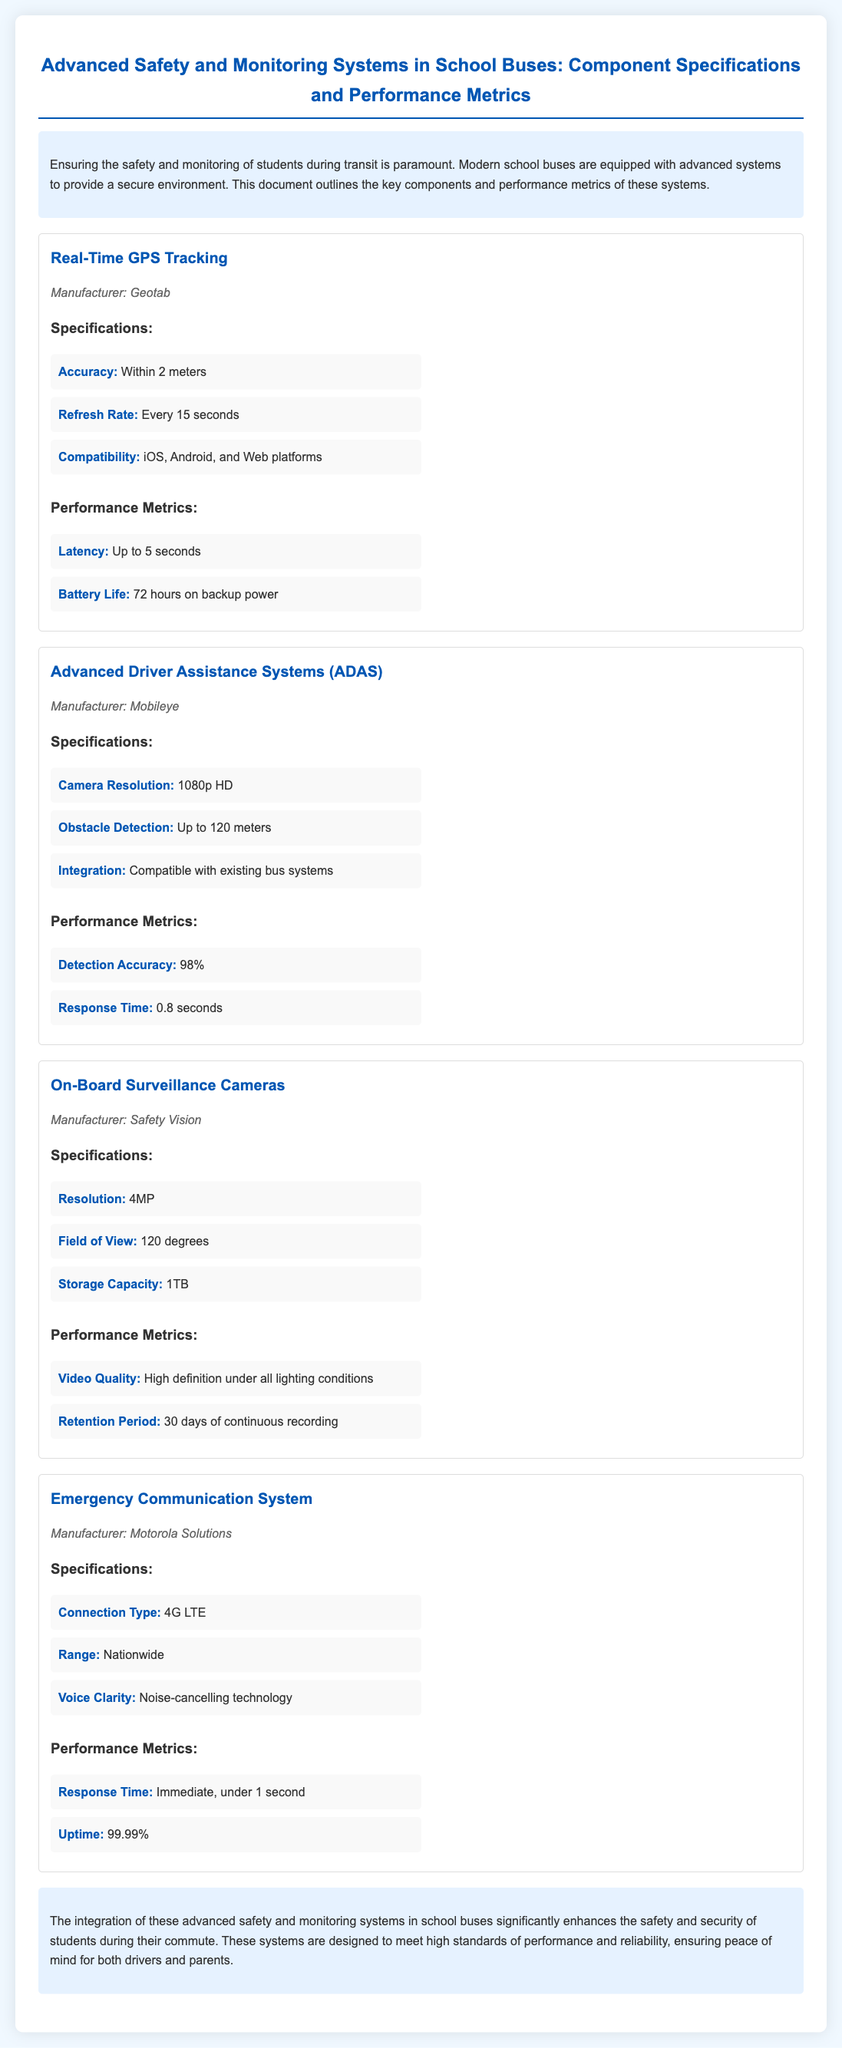What is the manufacturer of the Real-Time GPS Tracking system? The manufacturer of the Real-Time GPS Tracking system is listed in the document under the corresponding component.
Answer: Geotab What is the accuracy of the Advanced Driver Assistance Systems? The accuracy is specified within the component specifications of the Advanced Driver Assistance Systems section.
Answer: 98% How many days of continuous recording does the On-Board Surveillance Cameras retain footage? This detail is mentioned in the performance metrics of the On-Board Surveillance Cameras section.
Answer: 30 days What is the response time of the Emergency Communication System? The response time can be found in the performance metrics of the Emergency Communication System.
Answer: Immediate, under 1 second What is the battery life of the Real-Time GPS Tracking system on backup power? Battery life for the Real-Time GPS Tracking system is listed in the performance metrics of that section.
Answer: 72 hours What type of connection does the Emergency Communication System use? This information is provided in the specifications of the Emergency Communication System section.
Answer: 4G LTE What is the field of view for the On-Board Surveillance Cameras? The field of view is detailed in the specifications section for the On-Board Surveillance Cameras.
Answer: 120 degrees What is the storage capacity of the On-Board Surveillance Cameras? The storage capacity is mentioned under the specifications of the On-Board Surveillance Cameras.
Answer: 1TB 